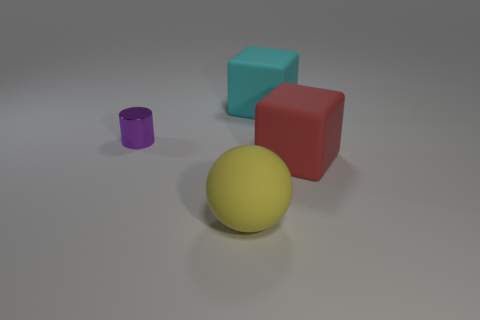Is there any other thing that has the same material as the large cyan block?
Keep it short and to the point. Yes. There is a small thing; is it the same color as the block behind the tiny metal object?
Your answer should be compact. No. The large red matte thing has what shape?
Your answer should be compact. Cube. There is a cylinder behind the red matte cube in front of the large matte object that is behind the large red matte object; what is its size?
Your answer should be compact. Small. What number of other things are the same shape as the red thing?
Give a very brief answer. 1. Does the large object that is behind the metallic thing have the same shape as the rubber thing that is in front of the red block?
Your answer should be very brief. No. How many spheres are small metallic things or big yellow rubber objects?
Keep it short and to the point. 1. What is the material of the thing that is on the left side of the rubber object in front of the large rubber cube that is in front of the cyan object?
Keep it short and to the point. Metal. How many other objects are the same size as the cyan thing?
Keep it short and to the point. 2. Are there more rubber spheres that are on the right side of the cyan object than tiny cyan cylinders?
Give a very brief answer. No. 